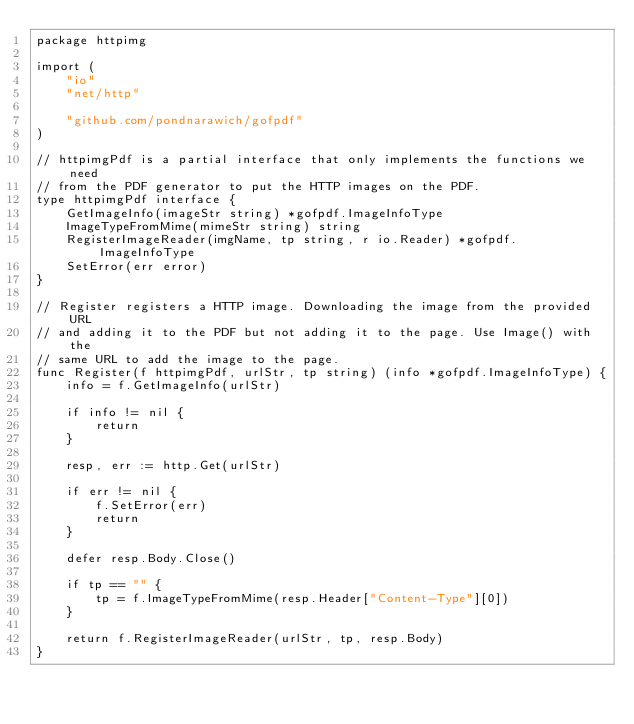Convert code to text. <code><loc_0><loc_0><loc_500><loc_500><_Go_>package httpimg

import (
	"io"
	"net/http"

	"github.com/pondnarawich/gofpdf"
)

// httpimgPdf is a partial interface that only implements the functions we need
// from the PDF generator to put the HTTP images on the PDF.
type httpimgPdf interface {
	GetImageInfo(imageStr string) *gofpdf.ImageInfoType
	ImageTypeFromMime(mimeStr string) string
	RegisterImageReader(imgName, tp string, r io.Reader) *gofpdf.ImageInfoType
	SetError(err error)
}

// Register registers a HTTP image. Downloading the image from the provided URL
// and adding it to the PDF but not adding it to the page. Use Image() with the
// same URL to add the image to the page.
func Register(f httpimgPdf, urlStr, tp string) (info *gofpdf.ImageInfoType) {
	info = f.GetImageInfo(urlStr)

	if info != nil {
		return
	}

	resp, err := http.Get(urlStr)

	if err != nil {
		f.SetError(err)
		return
	}

	defer resp.Body.Close()

	if tp == "" {
		tp = f.ImageTypeFromMime(resp.Header["Content-Type"][0])
	}

	return f.RegisterImageReader(urlStr, tp, resp.Body)
}
</code> 